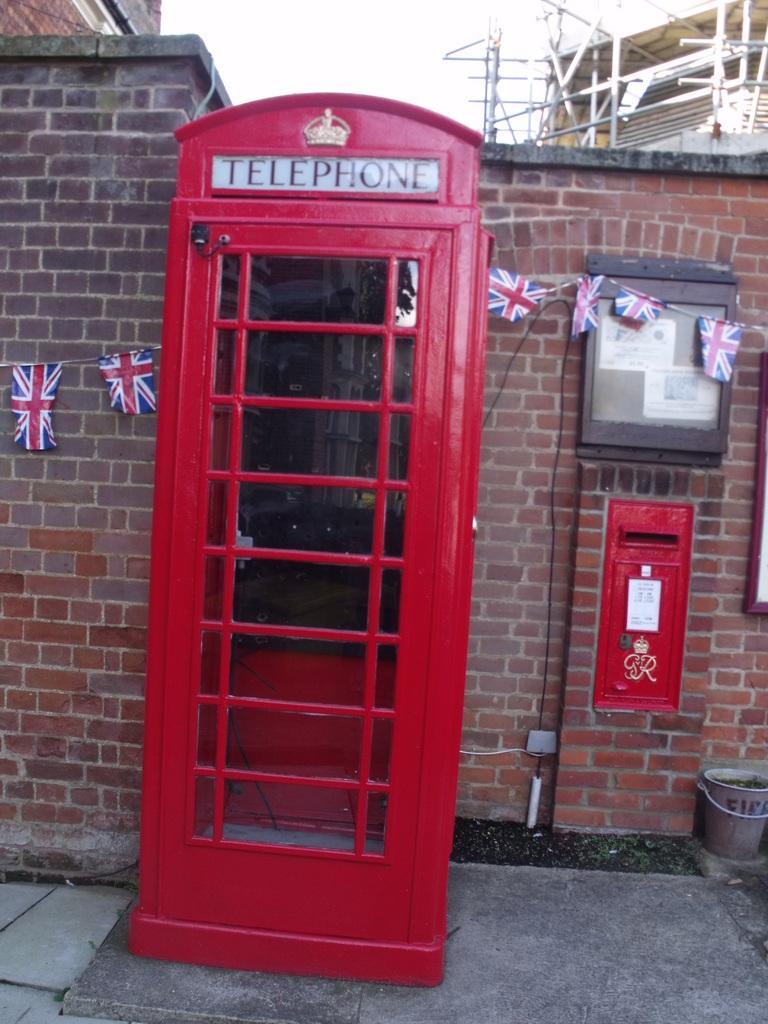Could you give a brief overview of what you see in this image? In the image there is a telephone booth in front of a brick wall and above its sky. 